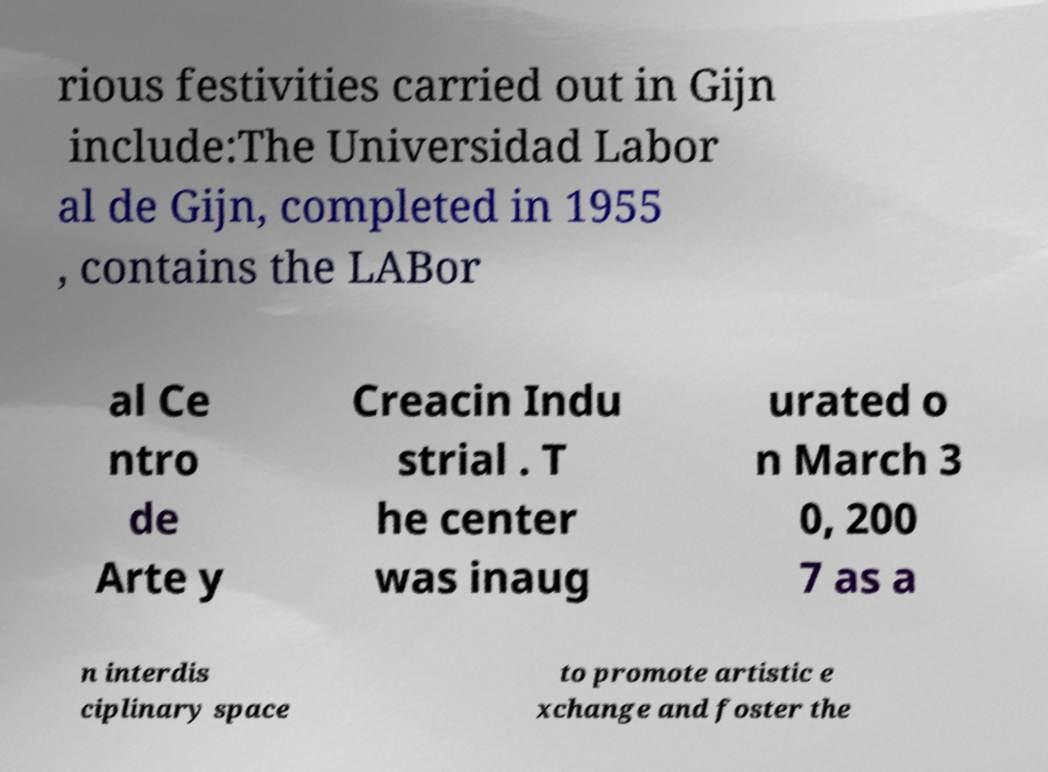Can you read and provide the text displayed in the image?This photo seems to have some interesting text. Can you extract and type it out for me? rious festivities carried out in Gijn include:The Universidad Labor al de Gijn, completed in 1955 , contains the LABor al Ce ntro de Arte y Creacin Indu strial . T he center was inaug urated o n March 3 0, 200 7 as a n interdis ciplinary space to promote artistic e xchange and foster the 